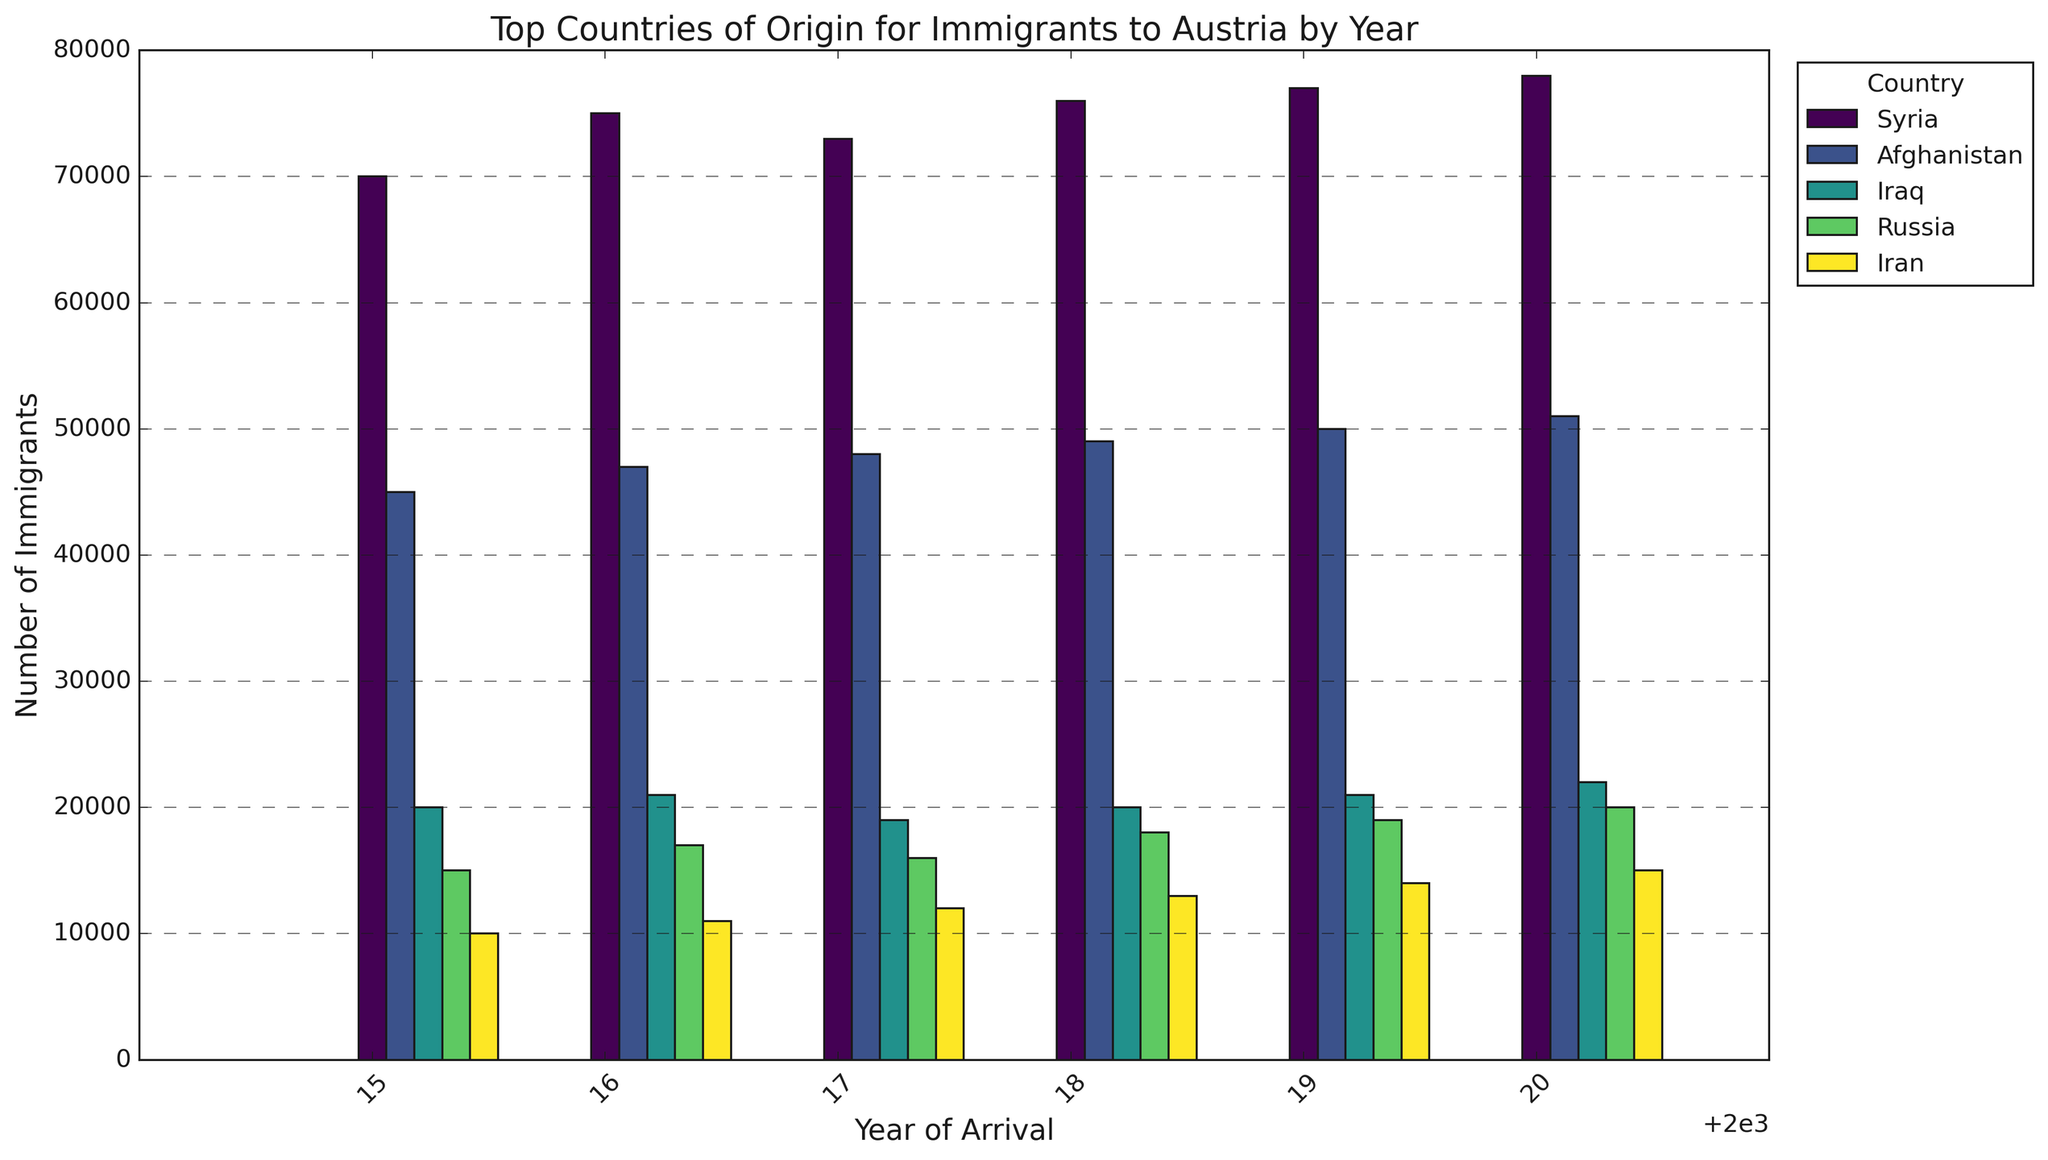What's the total number of immigrants from Syria in all the years combined? First, sum the data points for Syria across all the years: 70000 + 75000 + 73000 + 76000 + 77000 + 78000. The result is 449000.
Answer: 449000 How did the number of immigrants from Afghanistan in 2015 compare to 2020? The number of immigrants from Afghanistan in 2015 is 45000, and in 2020, it is 51000. 51000 - 45000 = 6000 more immigrants in 2020 compared to 2015.
Answer: 6000 more in 2020 Which country had the fewest immigrants in 2018 and how many were there? In 2018, the count of immigrants from each country is: Syria (76000), Afghanistan (49000), Iraq (20000), Russia (18000), and Iran (13000). The fewest is from Iran with 13000 immigrants.
Answer: Iran, 13000 Did the number of immigrants from Iraq increase or decrease from 2017 to 2018 and by how much? In 2017, the number of immigrants from Iraq is 19000. In 2018, it is 20000. 20000 - 19000 = an increase of 1000 immigrants.
Answer: Increase, 1000 more Which country had the highest number of immigrants consistently from 2015 to 2020? Syria had the highest number of immigrants each year from 2015 to 2020.
Answer: Syria What was the average number of immigrants from Iran over the years provided? Sum the number of immigrants from Iran for each year and divide by the number of years: (10000 + 11000 + 12000 + 13000 + 14000 + 15000)/6 = 12500.
Answer: 12500 Compare the growth rate of immigrants from Syria between 2015 and 2016 with that between 2019 and 2020. Between 2015 (70000) and 2016 (75000), the increase is 5000. Between 2019 (77000) and 2020 (78000), the increase is 1000. 5000 vs 1000 indicates higher growth from 2015 to 2016.
Answer: Higher growth from 2015 to 2016 Which country showed the smallest change in the number of immigrants over the years and what is the total change? Calculate the change for each country from 2015 to 2020 and find the smallest: Syria (8000), Afghanistan (6000), Iraq (2000), Russia (5000), Iran (5000). Iraq showed the smallest change with a total change of 2000 immigrants.
Answer: Iraq, 2000 How many more immigrants were from Syria than Iran in 2020? In 2020, the number of immigrants from Syria is 78000, and from Iran is 15000. The difference is 78000 - 15000 = 63000.
Answer: 63000 What percentage of total immigrants did Afghanistan account for in 2019? First, sum the total number of immigrants in 2019, then find the percentage for Afghanistan: 77000 (Syria) + 50000 (Afghanistan) + 21000 (Iraq) + 19000 (Russia) + 14000 (Iran) = 181000. Afghanistan's share is (50000/181000)*100 ≈ 27.6%.
Answer: 27.6% 